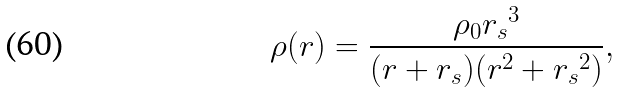<formula> <loc_0><loc_0><loc_500><loc_500>\rho ( r ) = \frac { \rho _ { 0 } { r _ { s } } ^ { 3 } } { ( r + r _ { s } ) ( r ^ { 2 } + { r _ { s } } ^ { 2 } ) } ,</formula> 